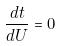Convert formula to latex. <formula><loc_0><loc_0><loc_500><loc_500>\frac { d t } { d U } = 0</formula> 